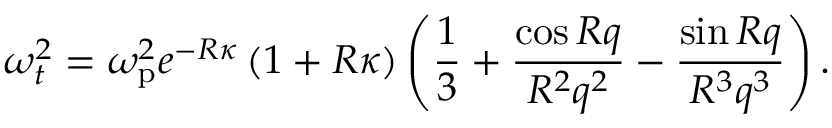Convert formula to latex. <formula><loc_0><loc_0><loc_500><loc_500>\omega _ { t } ^ { 2 } = \omega _ { p } ^ { 2 } e ^ { - R \kappa } \left ( 1 + R \kappa \right ) \left ( \frac { 1 } { 3 } + \frac { \cos R q } { R ^ { 2 } q ^ { 2 } } - \frac { \sin R q } { R ^ { 3 } q ^ { 3 } } \right ) .</formula> 